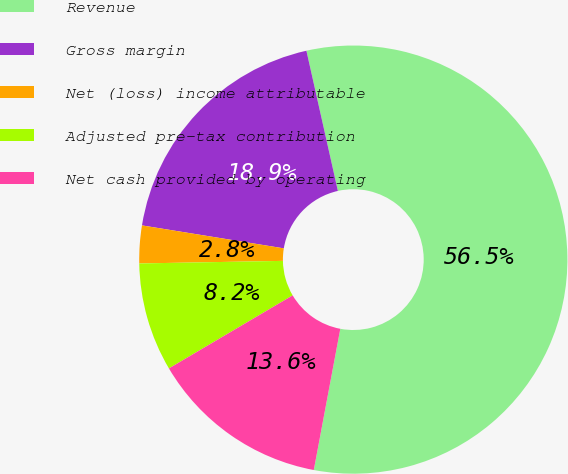Convert chart. <chart><loc_0><loc_0><loc_500><loc_500><pie_chart><fcel>Revenue<fcel>Gross margin<fcel>Net (loss) income attributable<fcel>Adjusted pre-tax contribution<fcel>Net cash provided by operating<nl><fcel>56.47%<fcel>18.93%<fcel>2.84%<fcel>8.2%<fcel>13.56%<nl></chart> 